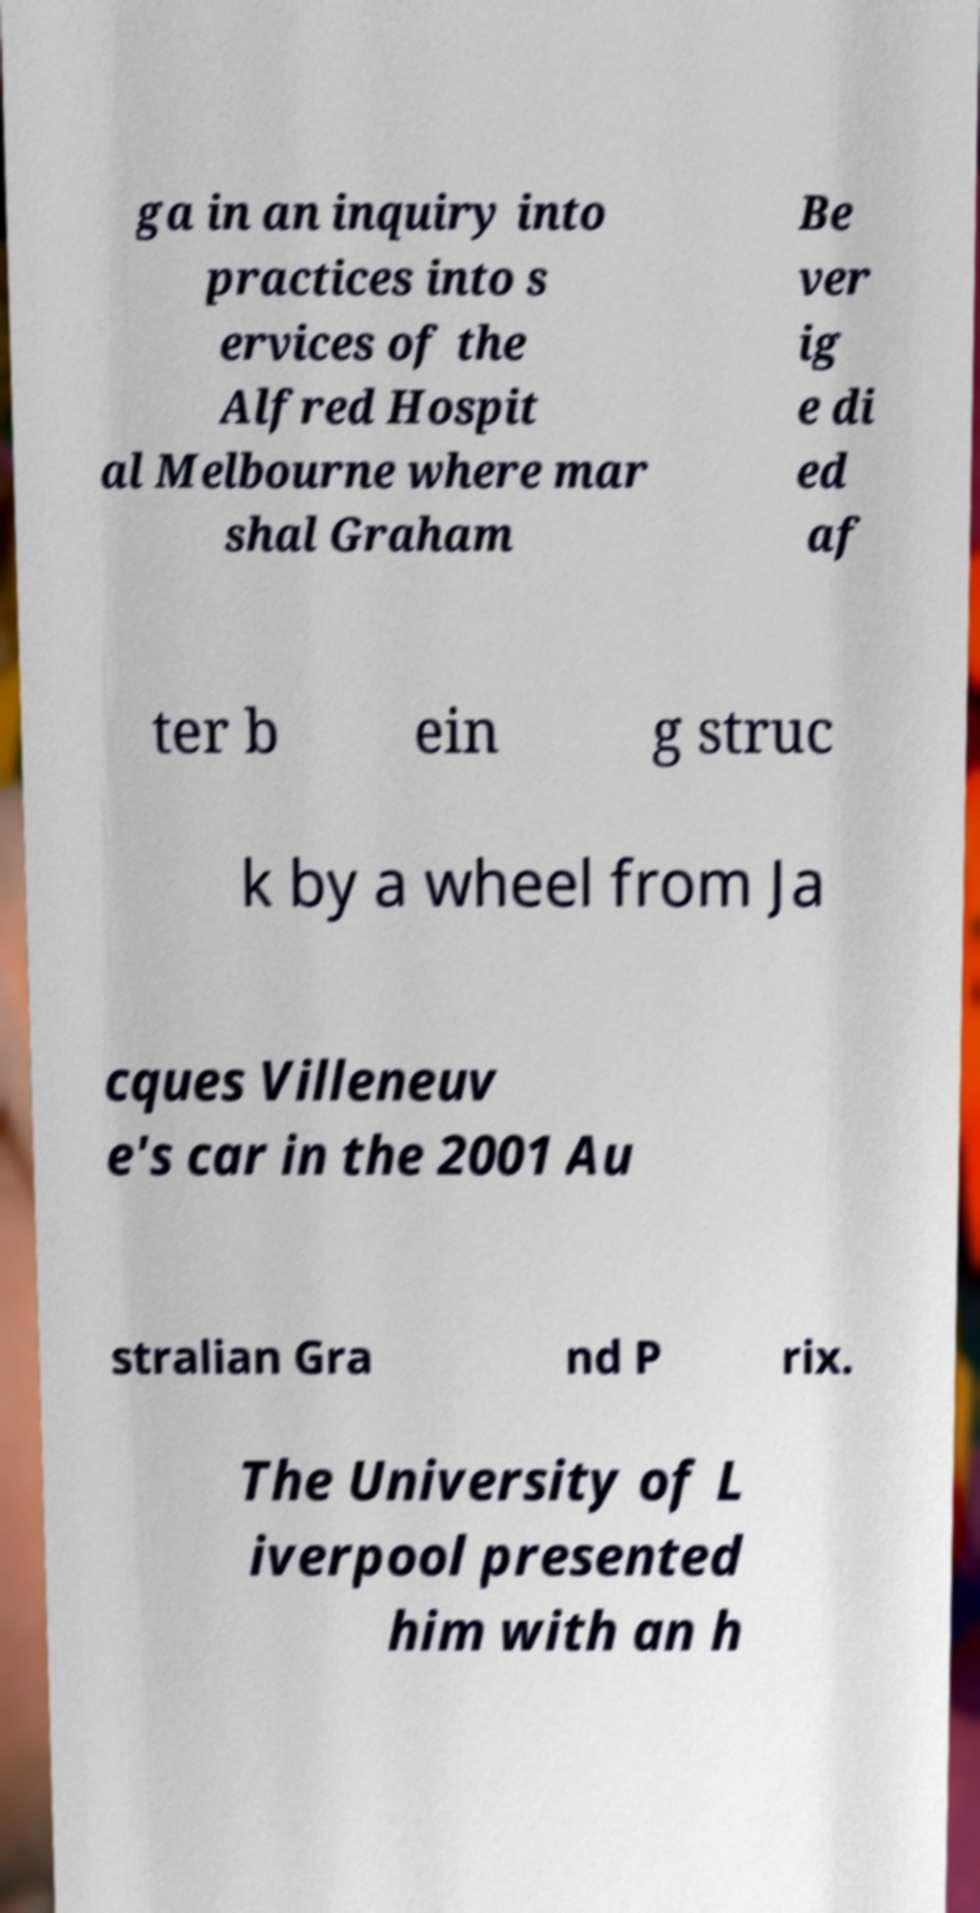There's text embedded in this image that I need extracted. Can you transcribe it verbatim? ga in an inquiry into practices into s ervices of the Alfred Hospit al Melbourne where mar shal Graham Be ver ig e di ed af ter b ein g struc k by a wheel from Ja cques Villeneuv e's car in the 2001 Au stralian Gra nd P rix. The University of L iverpool presented him with an h 